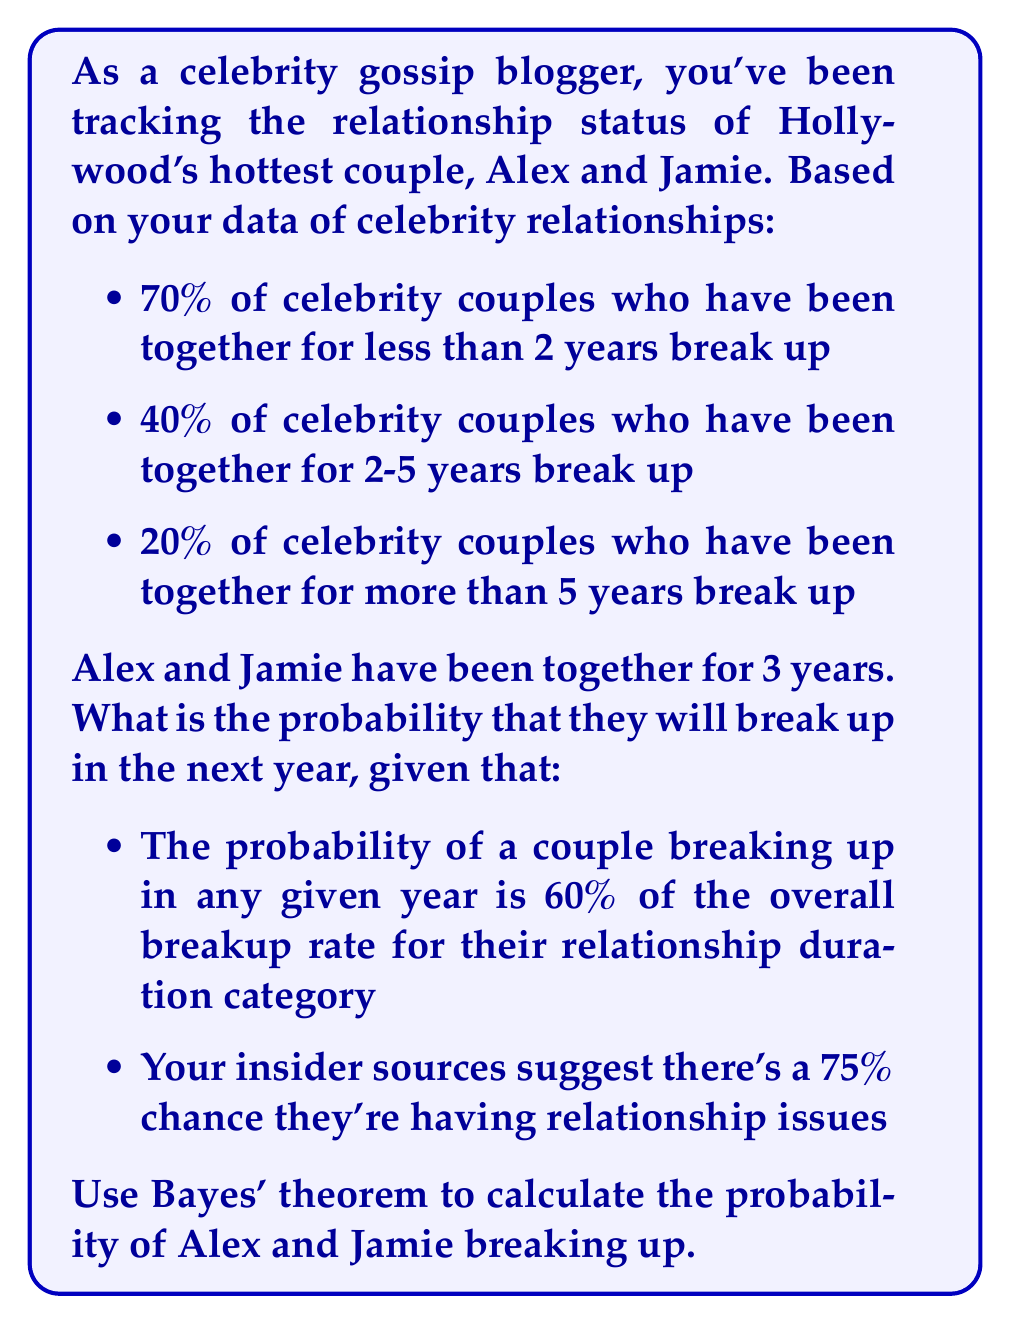Can you solve this math problem? Let's approach this step-by-step using Bayes' theorem:

1) Define our events:
   B = Alex and Jamie break up
   I = They're having relationship issues

2) We need to calculate P(B|I) using Bayes' theorem:

   $$P(B|I) = \frac{P(I|B) \cdot P(B)}{P(I)}$$

3) Calculate P(B):
   - They've been together for 3 years, so they're in the 2-5 years category
   - Overall breakup rate for this category: 40%
   - Probability of breaking up in a year: 60% of 40% = 0.6 * 0.4 = 0.24
   
   So, P(B) = 0.24

4) We're given P(I) = 0.75

5) To find P(I|B), we need to make an assumption. Let's assume that if they're going to break up, there's a 90% chance they're having issues.

   So, P(I|B) = 0.9

6) Now we can apply Bayes' theorem:

   $$P(B|I) = \frac{0.9 \cdot 0.24}{0.75} = 0.288$$

7) Convert to a percentage: 0.288 * 100 = 28.8%
Answer: 28.8% 